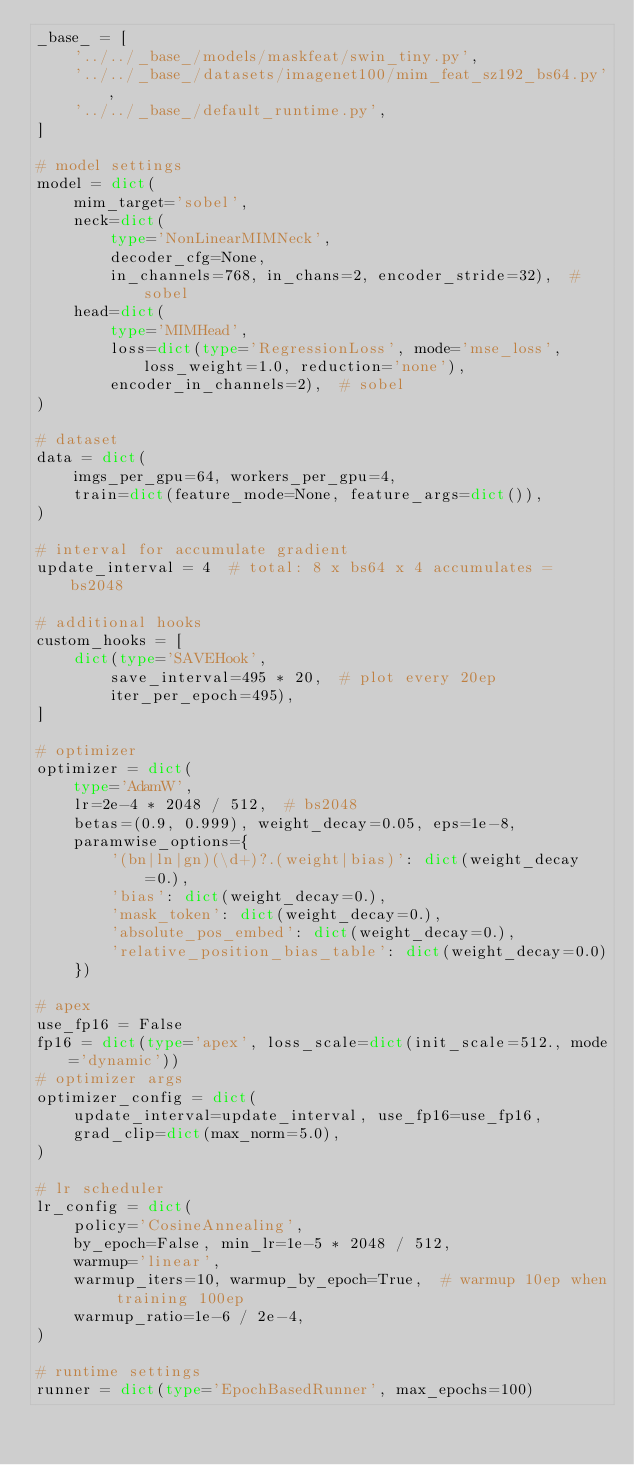Convert code to text. <code><loc_0><loc_0><loc_500><loc_500><_Python_>_base_ = [
    '../../_base_/models/maskfeat/swin_tiny.py',
    '../../_base_/datasets/imagenet100/mim_feat_sz192_bs64.py',
    '../../_base_/default_runtime.py',
]

# model settings
model = dict(
    mim_target='sobel',
    neck=dict(
        type='NonLinearMIMNeck',
        decoder_cfg=None,
        in_channels=768, in_chans=2, encoder_stride=32),  # sobel
    head=dict(
        type='MIMHead',
        loss=dict(type='RegressionLoss', mode='mse_loss', loss_weight=1.0, reduction='none'),
        encoder_in_channels=2),  # sobel
)

# dataset
data = dict(
    imgs_per_gpu=64, workers_per_gpu=4,
    train=dict(feature_mode=None, feature_args=dict()),
)

# interval for accumulate gradient
update_interval = 4  # total: 8 x bs64 x 4 accumulates = bs2048

# additional hooks
custom_hooks = [
    dict(type='SAVEHook',
        save_interval=495 * 20,  # plot every 20ep
        iter_per_epoch=495),
]

# optimizer
optimizer = dict(
    type='AdamW',
    lr=2e-4 * 2048 / 512,  # bs2048
    betas=(0.9, 0.999), weight_decay=0.05, eps=1e-8,
    paramwise_options={
        '(bn|ln|gn)(\d+)?.(weight|bias)': dict(weight_decay=0.),
        'bias': dict(weight_decay=0.),
        'mask_token': dict(weight_decay=0.),
        'absolute_pos_embed': dict(weight_decay=0.),
        'relative_position_bias_table': dict(weight_decay=0.0)
    })

# apex
use_fp16 = False
fp16 = dict(type='apex', loss_scale=dict(init_scale=512., mode='dynamic'))
# optimizer args
optimizer_config = dict(
    update_interval=update_interval, use_fp16=use_fp16,
    grad_clip=dict(max_norm=5.0),
)

# lr scheduler
lr_config = dict(
    policy='CosineAnnealing',
    by_epoch=False, min_lr=1e-5 * 2048 / 512,
    warmup='linear',
    warmup_iters=10, warmup_by_epoch=True,  # warmup 10ep when training 100ep
    warmup_ratio=1e-6 / 2e-4,
)

# runtime settings
runner = dict(type='EpochBasedRunner', max_epochs=100)
</code> 